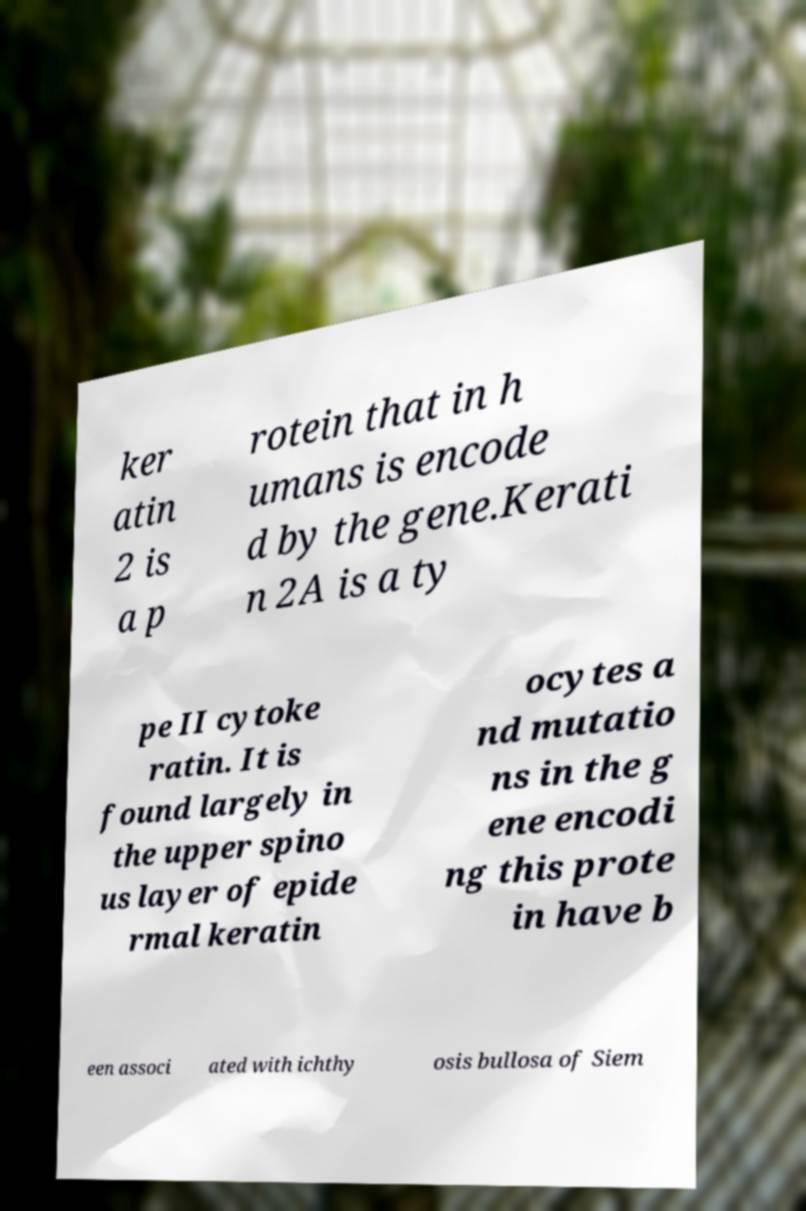Can you accurately transcribe the text from the provided image for me? ker atin 2 is a p rotein that in h umans is encode d by the gene.Kerati n 2A is a ty pe II cytoke ratin. It is found largely in the upper spino us layer of epide rmal keratin ocytes a nd mutatio ns in the g ene encodi ng this prote in have b een associ ated with ichthy osis bullosa of Siem 